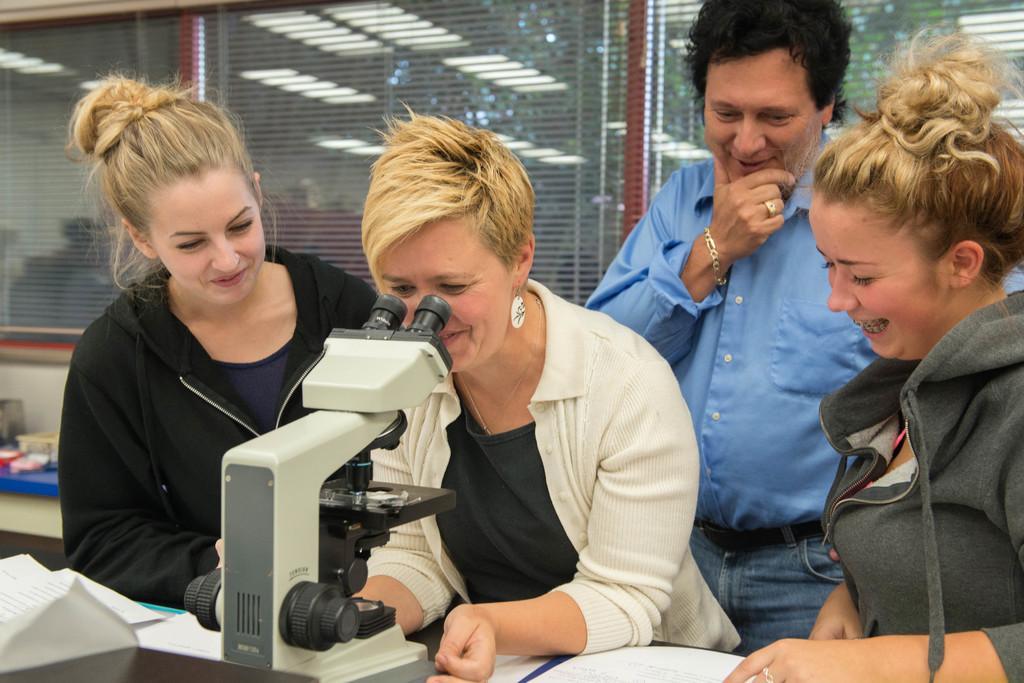In one or two sentences, can you explain what this image depicts? In this image we can see people standing and we can also see a microscope, windows and papers. 